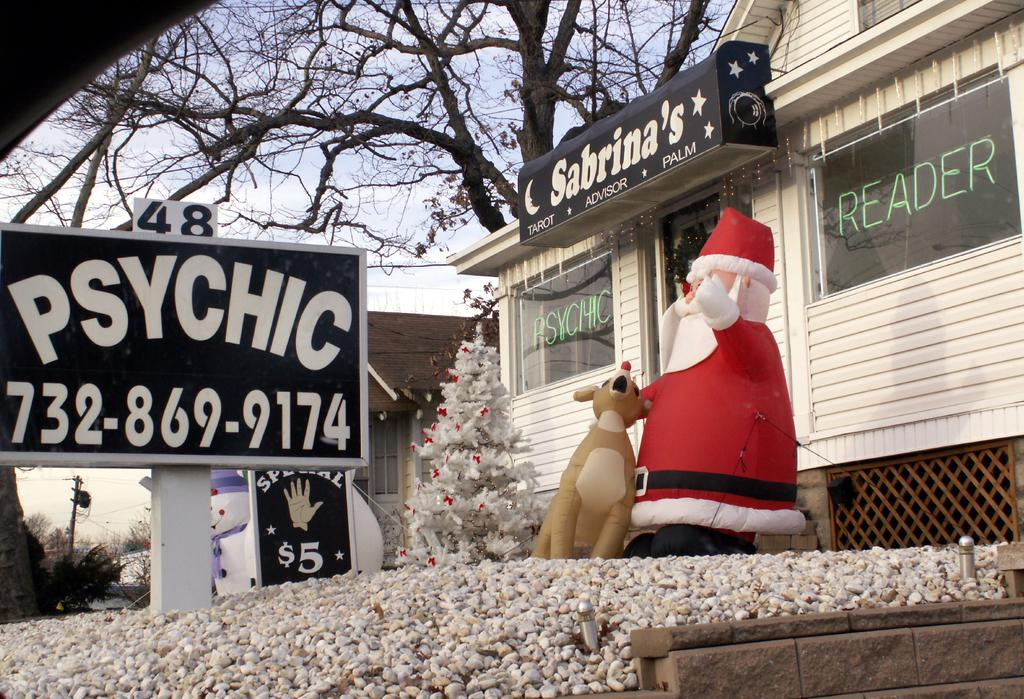What type of tree is featured in the image? There is a Christmas tree in the image. What other object can be seen in the image related to names or greetings? There is a name display board in the image. What is located in front of the house in the image? There are inflatable dolls in front of the house in the image. What type of natural element is visible behind the house in the image? There is a tree visible behind the house in the image. What type of scent can be detected from the cake in the image? There is no cake present in the image, so no scent can be detected. How does the dust affect the visibility of the tree in the image? There is no mention of dust in the image, so it cannot affect the visibility of the tree. 